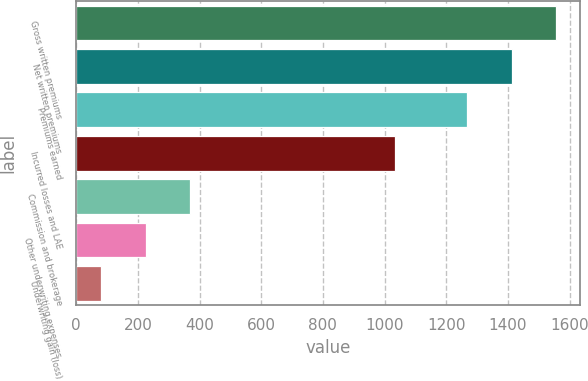Convert chart. <chart><loc_0><loc_0><loc_500><loc_500><bar_chart><fcel>Gross written premiums<fcel>Net written premiums<fcel>Premiums earned<fcel>Incurred losses and LAE<fcel>Commission and brokerage<fcel>Other underwriting expenses<fcel>Underwriting gain (loss)<nl><fcel>1557.26<fcel>1411.98<fcel>1266.7<fcel>1033.3<fcel>370.06<fcel>224.78<fcel>79.5<nl></chart> 